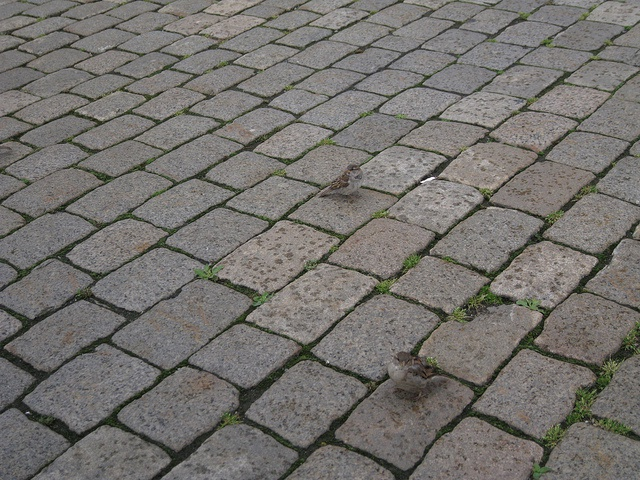Describe the objects in this image and their specific colors. I can see bird in gray and black tones and bird in gray and black tones in this image. 